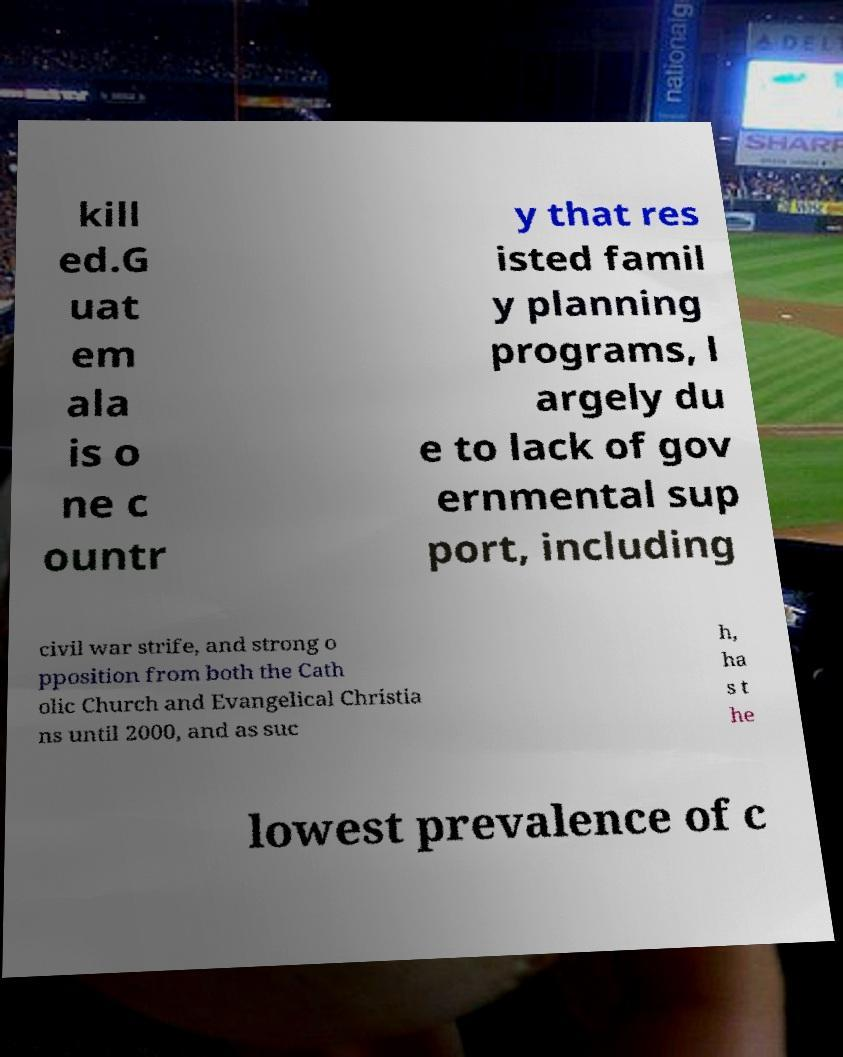Can you read and provide the text displayed in the image?This photo seems to have some interesting text. Can you extract and type it out for me? kill ed.G uat em ala is o ne c ountr y that res isted famil y planning programs, l argely du e to lack of gov ernmental sup port, including civil war strife, and strong o pposition from both the Cath olic Church and Evangelical Christia ns until 2000, and as suc h, ha s t he lowest prevalence of c 